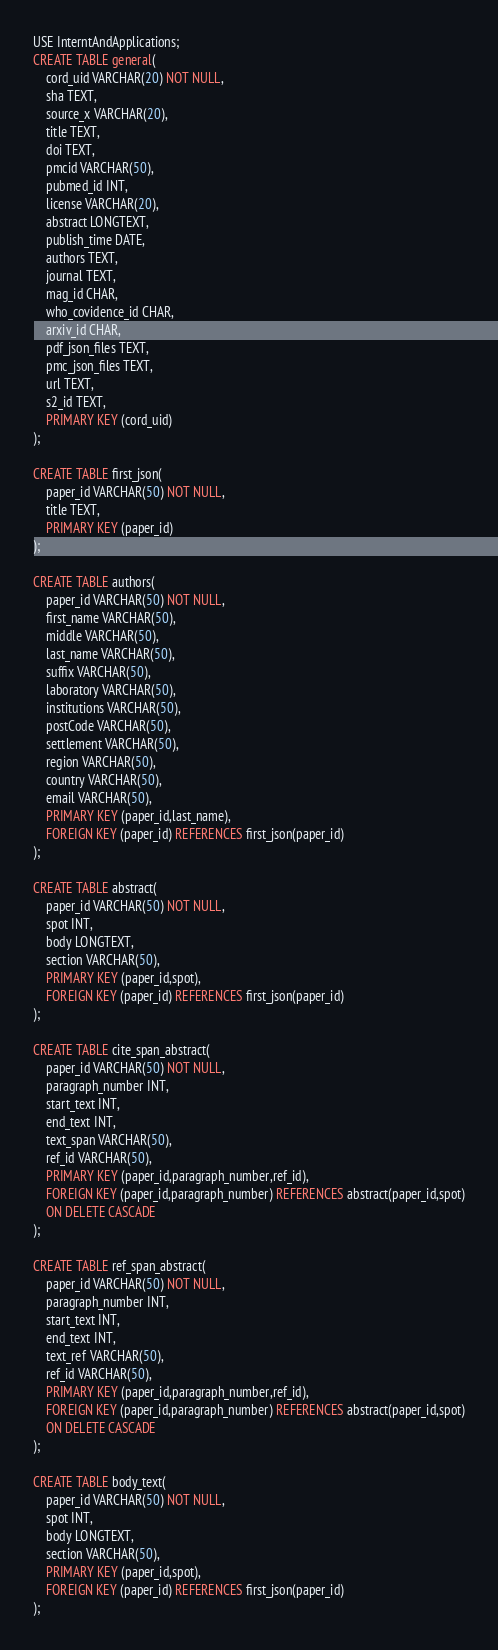Convert code to text. <code><loc_0><loc_0><loc_500><loc_500><_SQL_>USE InterntAndApplications;
CREATE TABLE general(
	cord_uid VARCHAR(20) NOT NULL,
    sha TEXT,
    source_x VARCHAR(20),
    title TEXT,
    doi TEXT,
    pmcid VARCHAR(50),
    pubmed_id INT,
    license VARCHAR(20),
    abstract LONGTEXT,
    publish_time DATE,
    authors TEXT,
    journal TEXT,
    mag_id CHAR,
    who_covidence_id CHAR,
    arxiv_id CHAR,
    pdf_json_files TEXT,
    pmc_json_files TEXT,
    url TEXT,
    s2_id TEXT,
    PRIMARY KEY (cord_uid)
);

CREATE TABLE first_json(
    paper_id VARCHAR(50) NOT NULL,
    title TEXT,
    PRIMARY KEY (paper_id)
);

CREATE TABLE authors(
    paper_id VARCHAR(50) NOT NULL,
    first_name VARCHAR(50),
    middle VARCHAR(50),
    last_name VARCHAR(50),
    suffix VARCHAR(50),
    laboratory VARCHAR(50),
    institutions VARCHAR(50),
    postCode VARCHAR(50),
    settlement VARCHAR(50),
    region VARCHAR(50),
    country VARCHAR(50),
    email VARCHAR(50),
    PRIMARY KEY (paper_id,last_name),
    FOREIGN KEY (paper_id) REFERENCES first_json(paper_id)
);

CREATE TABLE abstract(
    paper_id VARCHAR(50) NOT NULL,
    spot INT,
    body LONGTEXT,
    section VARCHAR(50),
    PRIMARY KEY (paper_id,spot),
    FOREIGN KEY (paper_id) REFERENCES first_json(paper_id)
);

CREATE TABLE cite_span_abstract(
    paper_id VARCHAR(50) NOT NULL,
    paragraph_number INT,
    start_text INT,
    end_text INT,
    text_span VARCHAR(50),
    ref_id VARCHAR(50),
    PRIMARY KEY (paper_id,paragraph_number,ref_id),
    FOREIGN KEY (paper_id,paragraph_number) REFERENCES abstract(paper_id,spot)
    ON DELETE CASCADE
);

CREATE TABLE ref_span_abstract(
    paper_id VARCHAR(50) NOT NULL,
    paragraph_number INT,
    start_text INT,
    end_text INT,
    text_ref VARCHAR(50),
    ref_id VARCHAR(50),
    PRIMARY KEY (paper_id,paragraph_number,ref_id),
    FOREIGN KEY (paper_id,paragraph_number) REFERENCES abstract(paper_id,spot)
    ON DELETE CASCADE
);

CREATE TABLE body_text(
    paper_id VARCHAR(50) NOT NULL,
    spot INT,
    body LONGTEXT,
    section VARCHAR(50),
    PRIMARY KEY (paper_id,spot),
    FOREIGN KEY (paper_id) REFERENCES first_json(paper_id)
);
</code> 